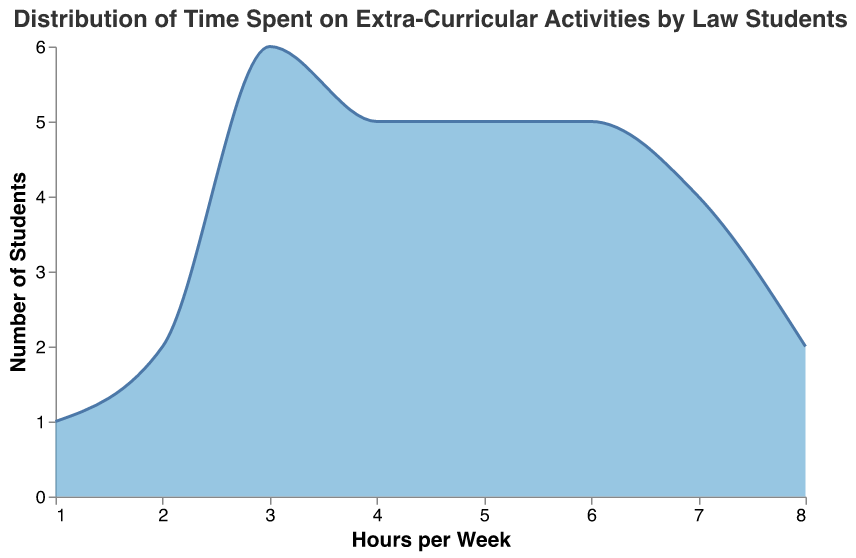What is the title of the plot? The title is usually located at the top of the plot and provides an overview of what the plot represents.
Answer: Distribution of Time Spent on Extra-Curricular Activities by Law Students What is the most common number of hours spent by law students on extra-curricular activities per week? By observing the peak of the distribution curve, we can identify the most frequent value on the x-axis where the curve reaches its highest point.
Answer: 3 hours How many students spend 7 hours per week on extra-curricular activities? Locate the point on the x-axis corresponding to 7 hours and check the height of the curve at that point to determine the number of students.
Answer: 4 students Which number of hours is the least common among law students? Identify the value on the x-axis where the curve is at its lowest or absent.
Answer: 1 hour Which range of hours has the highest concentration of students? Examine the shape of the distribution curve to identify where it is widest and highest, indicating more students in that range.
Answer: 3 to 6 hours Compare the number of students who spend 5 hours versus those who spend 4 hours on extra-curricular activities. Identify the heights of the curve at 5 hours and 4 hours, respectively, and compare these values to determine which is higher.
Answer: More students spend 5 hours What is the average time spent by students on extra-curricular activities? Calculate the average by summing the products of each hour value and its frequency, then dividing by the total number of students. This is a multi-step process:
1. Compute the total hours: (3 students * 3 hours + 3 students * 4 hours + 5 students * 5 hours + 4 students * 6 hours + 4 students * 7 hours + 2 students * 8 hours + 2 students * 2 hours + 1 student * 1 hour).
2. Total hours = (9 + 12 + 25 + 24 + 28 + 16 + 4 + 1) = 119 hours.
3. Total number of students = 30.
4. Average = 119 / 30.
Answer: ≈ 3.97 hours Is there any student who spends more than 8 hours a week on extra-curricular activities? Look at the x-axis and confirm the range of values. If the curve extends beyond 8 hours, then someone spends more, otherwise they don't.
Answer: No How many students spend between 2 and 5 hours on extra-curricular activities? Identify the area under the curve from 2 to 5 hours and count the number of students represented in that area.
Answer: 12 students Which value has a greater count: students spending 6 hours or 7 hours on extra-curricular activities? Compare the height of the distribution curve at 6 hours and 7 hours on the x-axis to see which is higher.
Answer: 6 hours 